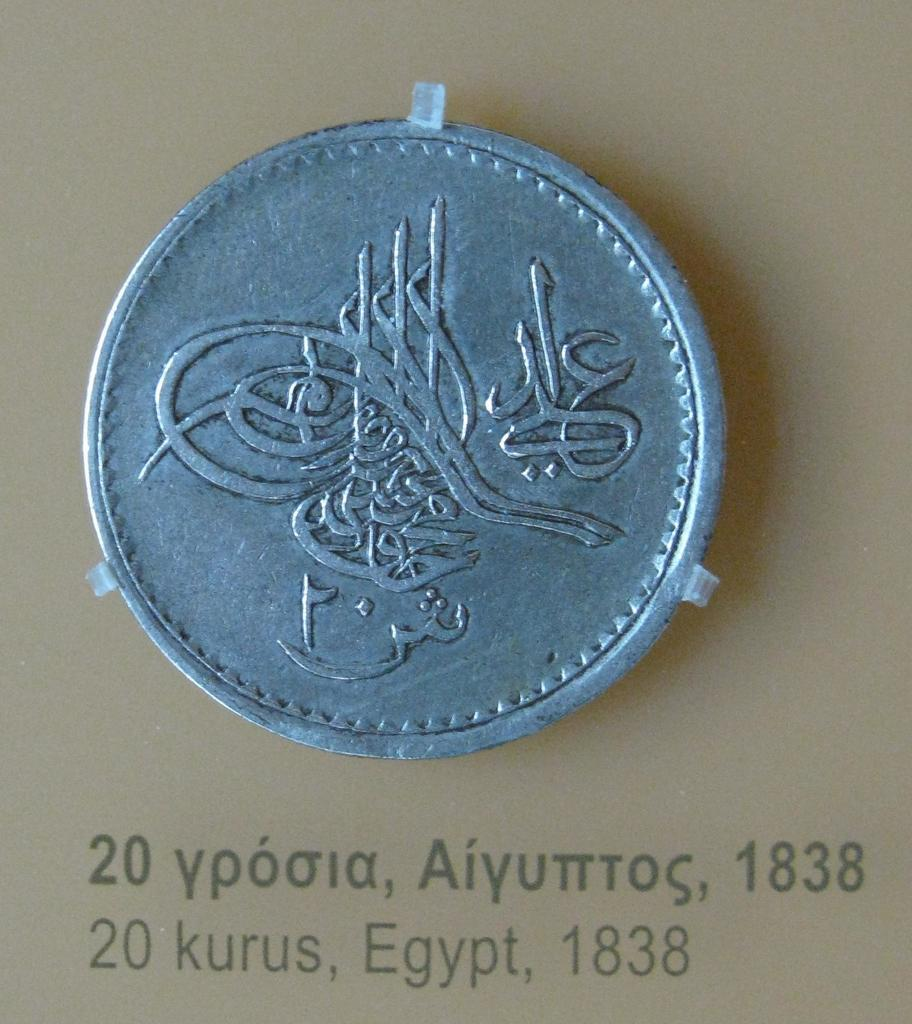<image>
Provide a brief description of the given image. A coin is displayed and below it the year 1838 appears. 